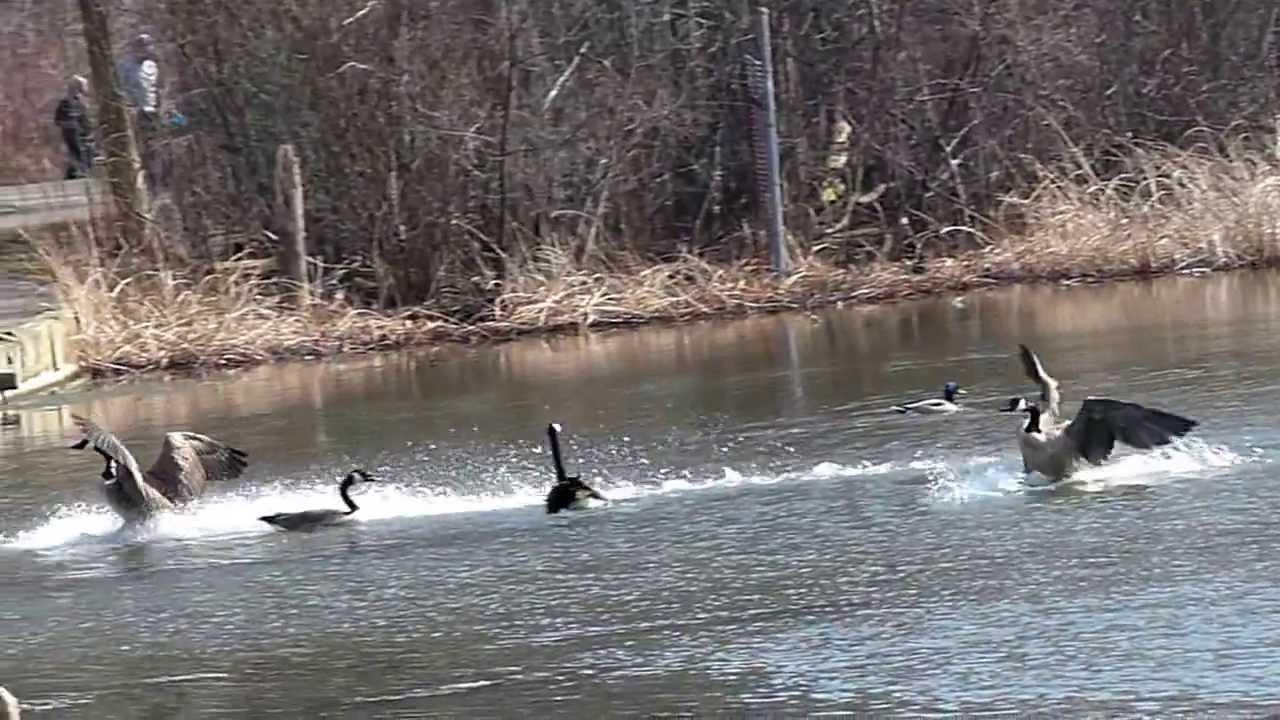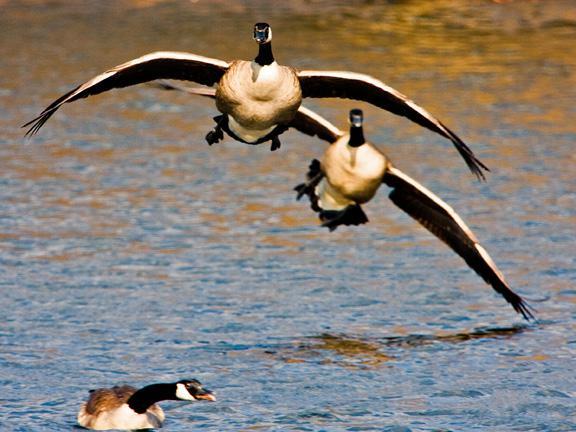The first image is the image on the left, the second image is the image on the right. Analyze the images presented: Is the assertion "There are two geese" valid? Answer yes or no. No. 